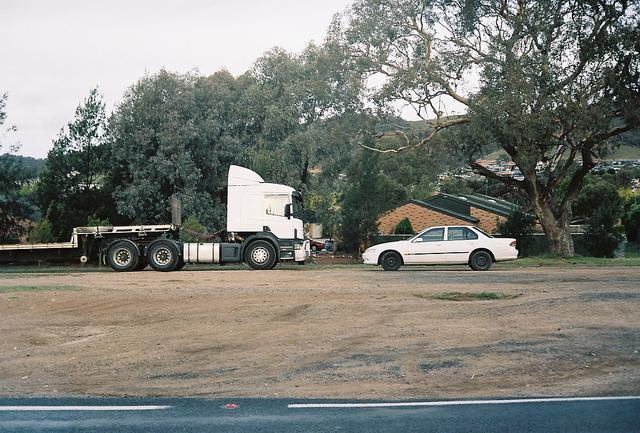What is this type of truck called? Please explain your reasoning. semi. This is a large truck that is used to pull heavy items. it has 18 wheels. 